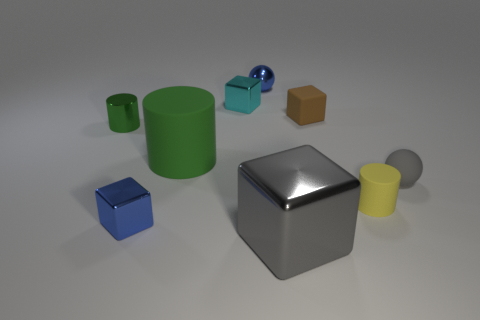Is the large matte cylinder the same color as the shiny cylinder?
Make the answer very short. Yes. There is a tiny rubber object that is the same shape as the gray metallic object; what is its color?
Your answer should be compact. Brown. What material is the small cylinder that is right of the blue block behind the gray block?
Offer a terse response. Rubber. There is a yellow object that is in front of the small green metal cylinder; does it have the same shape as the green matte object behind the small yellow rubber cylinder?
Your answer should be very brief. Yes. There is a block that is both behind the large gray metallic object and on the right side of the shiny ball; what is its size?
Offer a terse response. Small. How many other things are the same color as the matte cube?
Your answer should be compact. 0. Is the material of the large gray object in front of the small rubber cylinder the same as the brown object?
Your response must be concise. No. Are there any other things that have the same size as the brown rubber thing?
Offer a very short reply. Yes. Is the number of tiny green shiny cylinders that are on the right side of the tiny blue shiny sphere less than the number of brown objects to the right of the yellow cylinder?
Give a very brief answer. No. Are there any other things that are the same shape as the brown object?
Make the answer very short. Yes. 